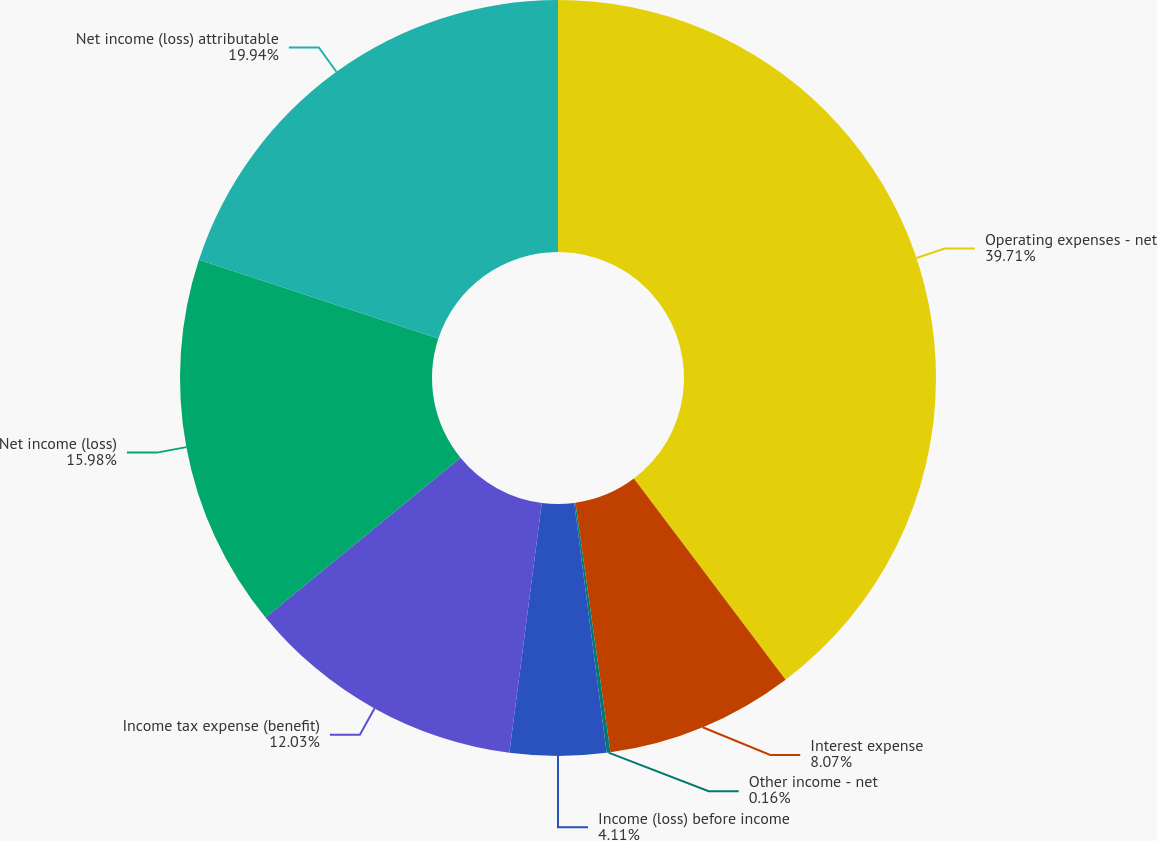Convert chart to OTSL. <chart><loc_0><loc_0><loc_500><loc_500><pie_chart><fcel>Operating expenses - net<fcel>Interest expense<fcel>Other income - net<fcel>Income (loss) before income<fcel>Income tax expense (benefit)<fcel>Net income (loss)<fcel>Net income (loss) attributable<nl><fcel>39.72%<fcel>8.07%<fcel>0.16%<fcel>4.11%<fcel>12.03%<fcel>15.98%<fcel>19.94%<nl></chart> 